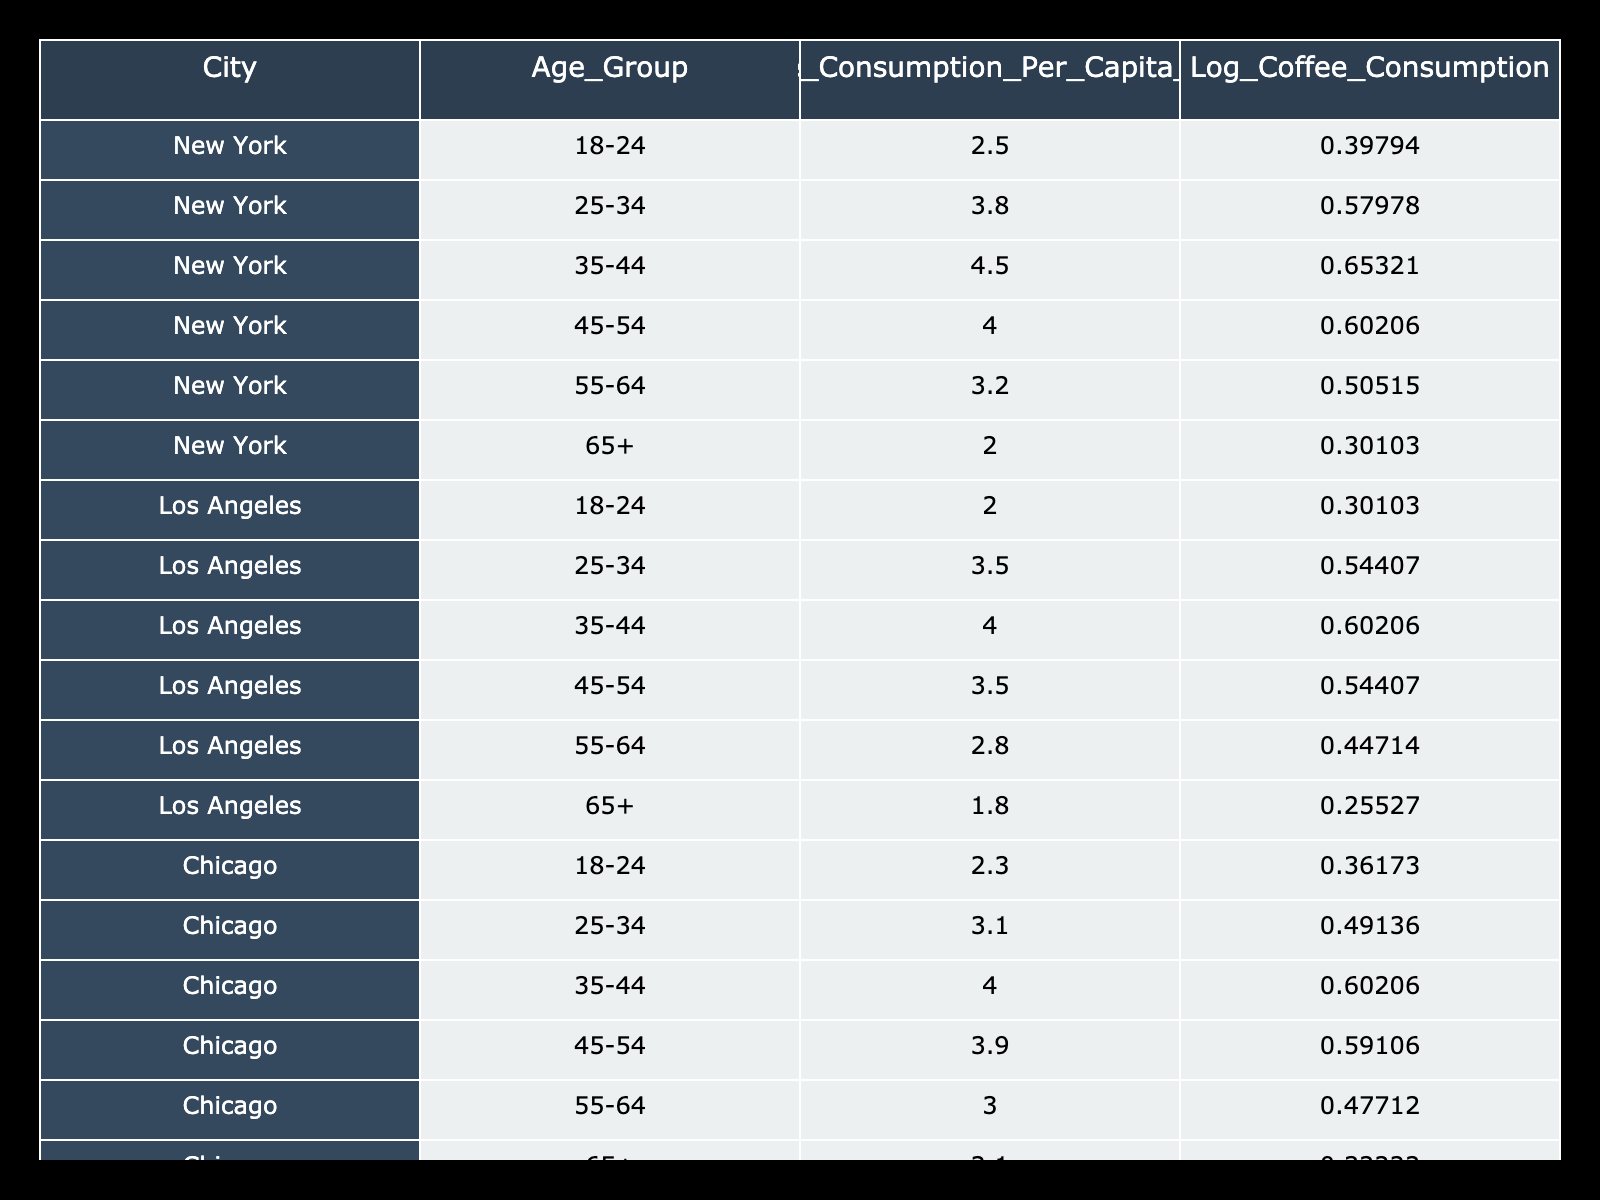What is the coffee consumption per capita for the age group 35-44 in New York? The table shows that for New York, the age group 35-44 has a coffee consumption per capita of 4.5 liters.
Answer: 4.5 liters Which city has the highest coffee consumption among the age group 25-34? Comparing the values for the age group 25-34 across all cities, San Francisco has the highest coffee consumption at 4.1 liters.
Answer: 4.1 liters Is the coffee consumption for the age group 65+ higher in Los Angeles than in Chicago? For Los Angeles, the coffee consumption for the age group 65+ is 1.8 liters, while in Chicago it is 2.1 liters. Since 1.8 is not higher than 2.1, the answer is no.
Answer: No What is the average coffee consumption per capita for the age group 45-54 across all cities? The consumption values for the age group 45-54 are: New York (4.0), Los Angeles (3.5), Chicago (3.9), San Francisco (3.8). The average is calculated as (4.0 + 3.5 + 3.9 + 3.8) / 4 = 3.815.
Answer: 3.815 liters In which city and age group is the coffee consumption the lowest? Looking at all values in the table, the lowest consumption is found in Los Angeles for the age group 65+ at 1.8 liters.
Answer: Los Angeles, 65+ 